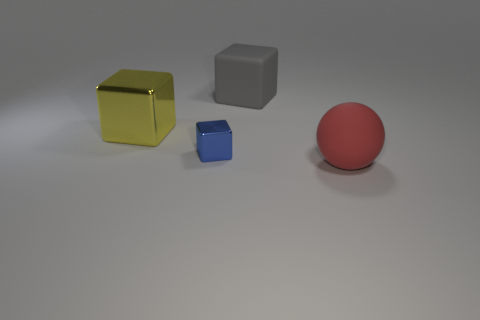There is a big yellow metal object; are there any things behind it?
Your response must be concise. Yes. What size is the blue shiny cube that is left of the large thing behind the big yellow metal object?
Give a very brief answer. Small. Is the number of large metal things in front of the yellow metallic cube the same as the number of tiny blue cubes behind the small object?
Your answer should be compact. Yes. There is a shiny cube that is in front of the yellow cube; is there a gray rubber block behind it?
Your answer should be compact. Yes. There is a rubber object behind the large matte thing that is in front of the tiny blue thing; how many rubber cubes are to the left of it?
Give a very brief answer. 0. Are there fewer tiny cyan balls than blue shiny things?
Your response must be concise. Yes. There is a small blue metal thing on the left side of the gray matte object; does it have the same shape as the big thing that is to the left of the small shiny object?
Your answer should be compact. Yes. The large metal object is what color?
Keep it short and to the point. Yellow. How many metallic objects are gray cubes or large balls?
Your answer should be very brief. 0. The other metal object that is the same shape as the yellow object is what color?
Keep it short and to the point. Blue. 